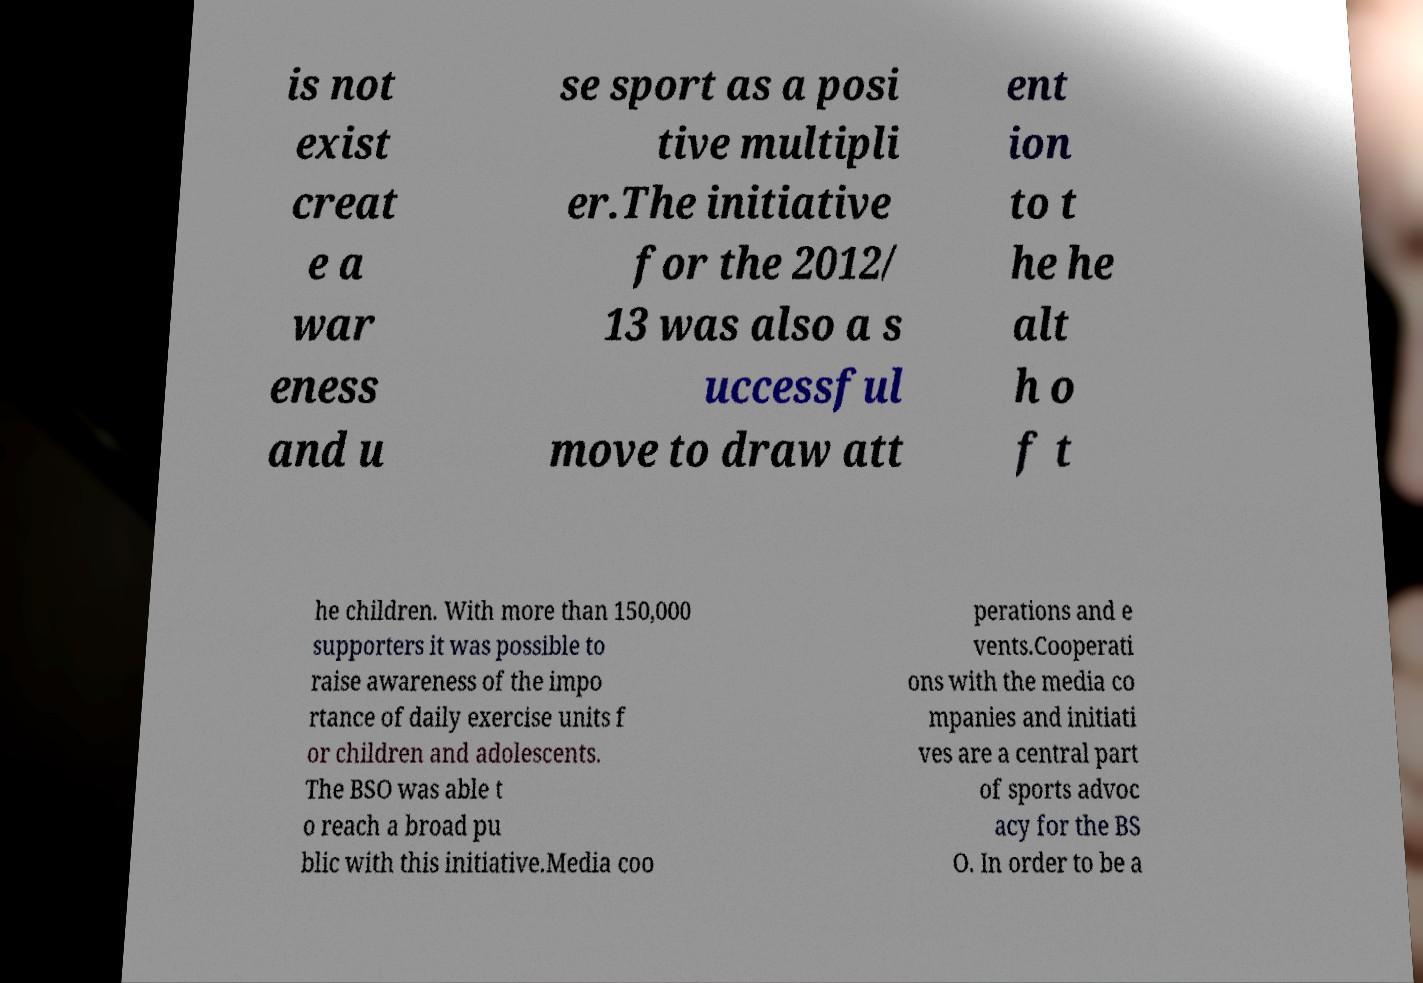Please read and relay the text visible in this image. What does it say? is not exist creat e a war eness and u se sport as a posi tive multipli er.The initiative for the 2012/ 13 was also a s uccessful move to draw att ent ion to t he he alt h o f t he children. With more than 150,000 supporters it was possible to raise awareness of the impo rtance of daily exercise units f or children and adolescents. The BSO was able t o reach a broad pu blic with this initiative.Media coo perations and e vents.Cooperati ons with the media co mpanies and initiati ves are a central part of sports advoc acy for the BS O. In order to be a 